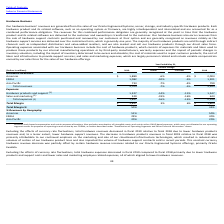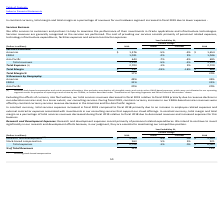Looking at Oracle Corporation's financial data, please calculate: How much more hardware revenues came from the Americas as compared to Asia Pacific in 2018?  Based on the calculation: 2,003 - 790, the result is 1213 (in millions). This is based on the information: "Asia Pacific 733 -7% -4% 790 Americas $ 1,889 -6% -4% $ 2,003..." The key data points involved are: 2,003, 790. Also, can you calculate: What was the sales and marketing expenses in 2019 and 2018? Based on the calculation: 520 + 643 , the result is 1163 (in millions). This is based on the information: "Sales and marketing (1) 520 -19% -16% 643 Sales and marketing (1) 520 -19% -16% 643..." The key data points involved are: 520, 643. Also, can you calculate: What was the difference in total margin comparing fiscal 2019 and 2018? Based on the calculation: 1,857 - 1,804, the result is 53 (in millions). This is based on the information: "Total Margin $ 1,857 3% 6% $ 1,804 Total Margin $ 1,857 3% 6% $ 1,804..." The key data points involved are: 1,804, 1,857. Also, How much was the constant percentage change and the actual percentage change in total margin ? The document shows two values: 6% and 3% (percentage). From the document: "Total expenses (1) 1,847 -16% -13% 2,190 Total expenses (1) 1,847 -16% -13% 2,190..." Also, What are the components that make up the company's hardware business' revenues? Our hardware business’ revenues are generated from the sales of our Oracle Engineered Systems, server, storage, and industry-specific hardware products.. The document states: "Our hardware business’ revenues are generated from the sales of our Oracle Engineered Systems, server, storage, and industry-specific hardware product..." Also, Why did the total hardware expense decrease in fiscal 2019 compared to fiscal 2018? Excluding the effects of currency rate fluctuations, total hardware expenses decreased in fiscal 2019 compared to fiscal 2018 primarily due to lower hardware products and support costs and lower sales and marketing employee related expenses, all of which aligned to lower hardware revenues.. The document states: "Excluding the effects of currency rate fluctuations, total hardware expenses decreased in fiscal 2019 compared to fiscal 2018 primarily due to lower h..." 